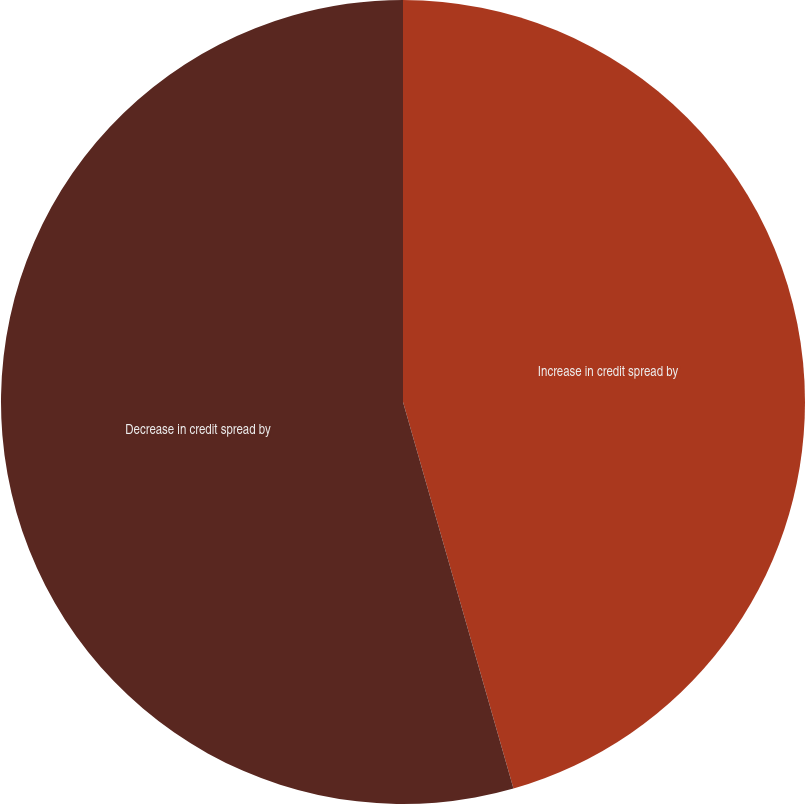Convert chart to OTSL. <chart><loc_0><loc_0><loc_500><loc_500><pie_chart><fcel>Increase in credit spread by<fcel>Decrease in credit spread by<nl><fcel>45.57%<fcel>54.43%<nl></chart> 